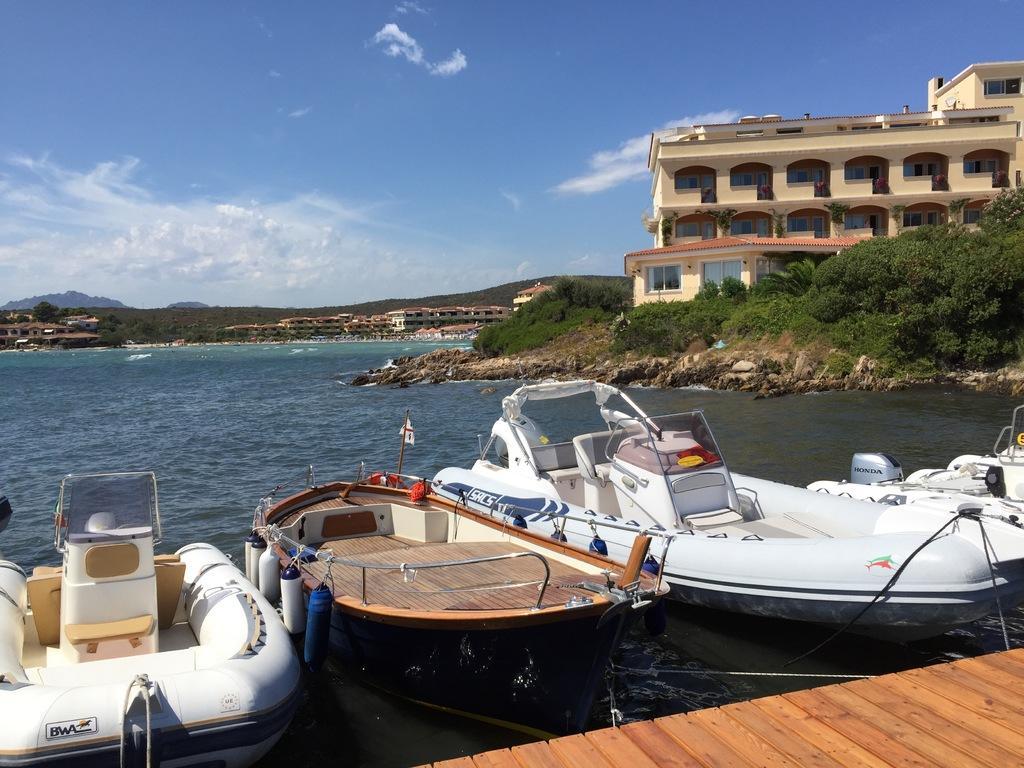Could you give a brief overview of what you see in this image? In this picture we can see a few boats in water. There are some buildings and trees on the right side. 